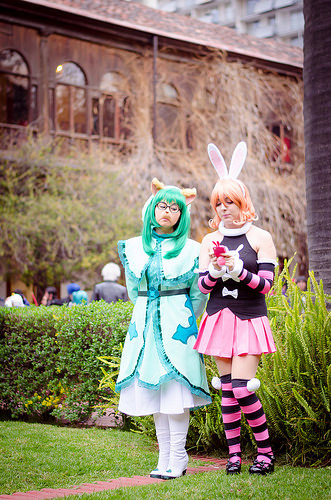<image>
Is the woman next to the bunny? Yes. The woman is positioned adjacent to the bunny, located nearby in the same general area. Is there a rabbit ears next to the woman? No. The rabbit ears is not positioned next to the woman. They are located in different areas of the scene. 